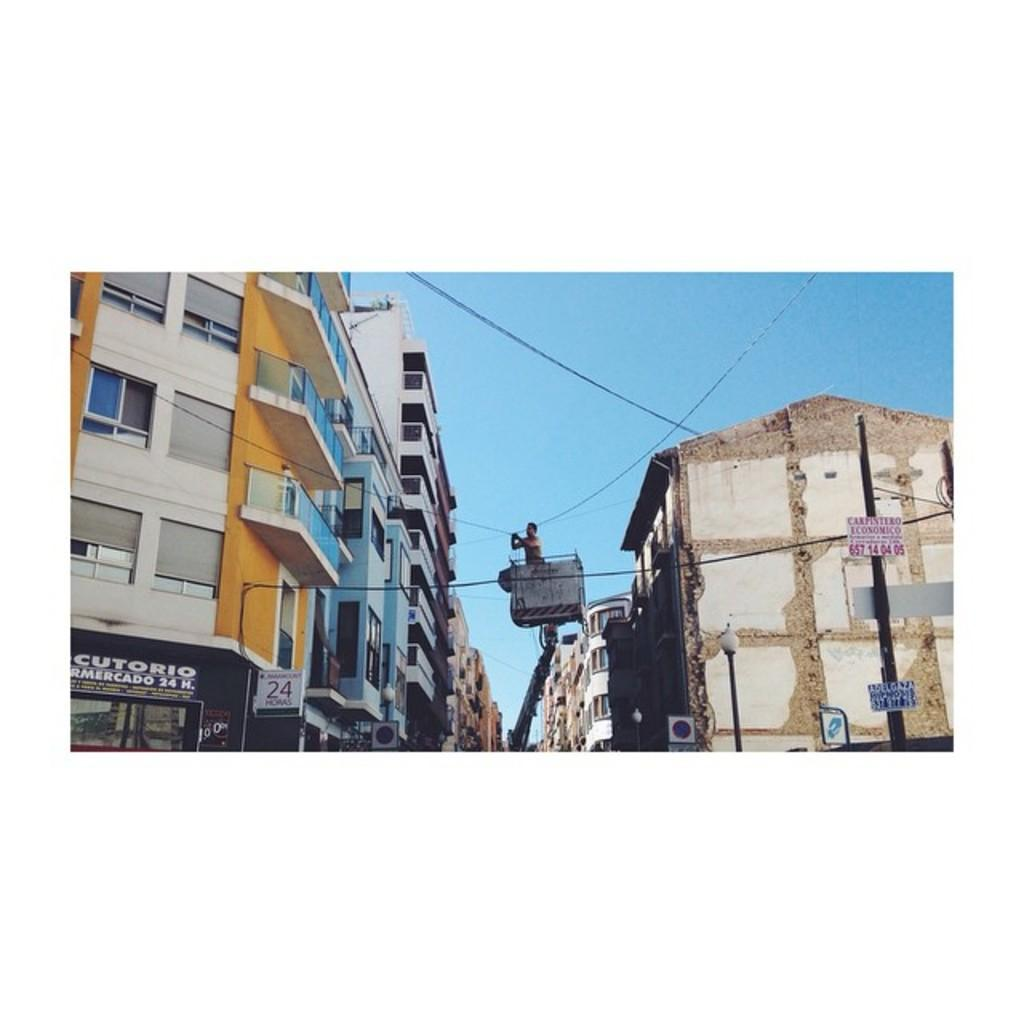What type of toy can be seen in the image? There is no toy present in the image. What type of trick is being performed in the image? There is no trick being performed in the image. What type of sticks are being used to stir the buildings in the image? There are no sticks present in the image, and the buildings are not being stirred. 